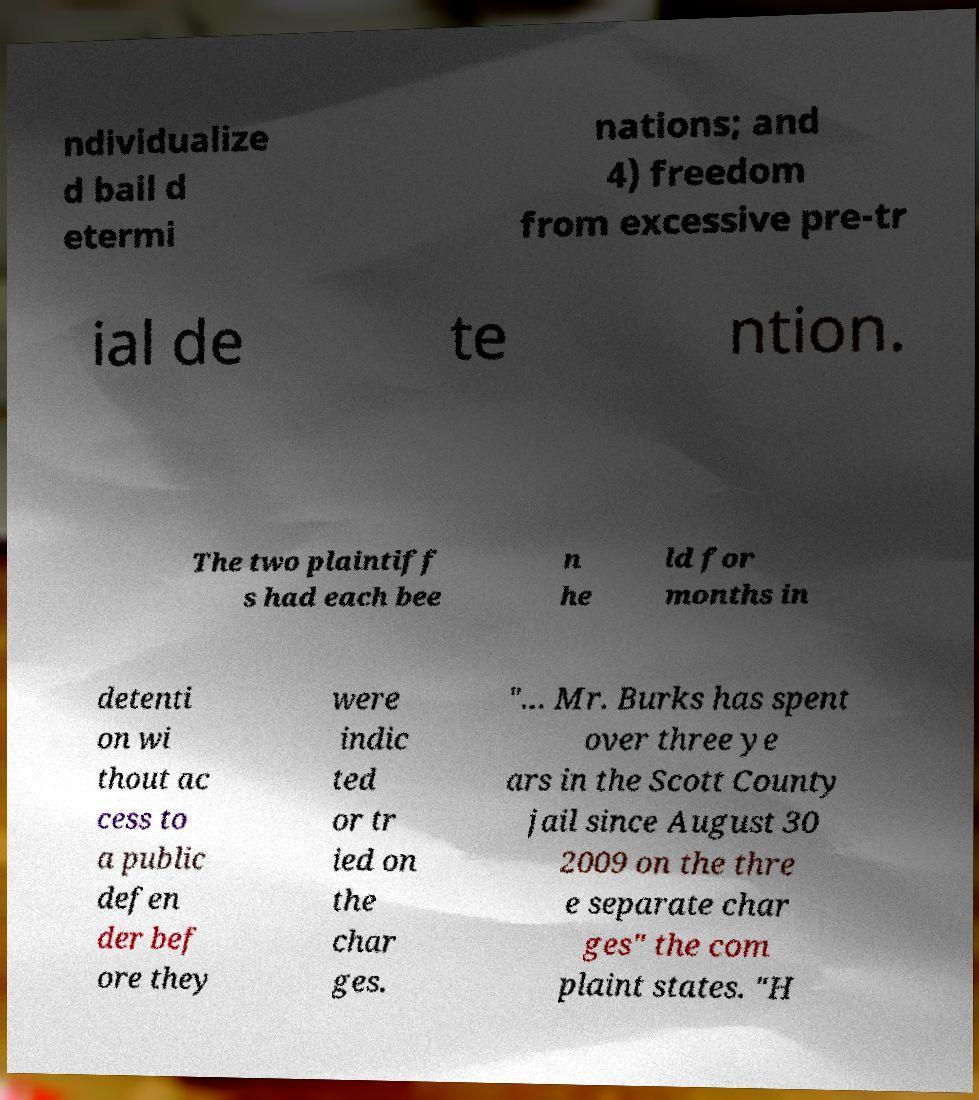I need the written content from this picture converted into text. Can you do that? ndividualize d bail d etermi nations; and 4) freedom from excessive pre-tr ial de te ntion. The two plaintiff s had each bee n he ld for months in detenti on wi thout ac cess to a public defen der bef ore they were indic ted or tr ied on the char ges. "... Mr. Burks has spent over three ye ars in the Scott County jail since August 30 2009 on the thre e separate char ges" the com plaint states. "H 